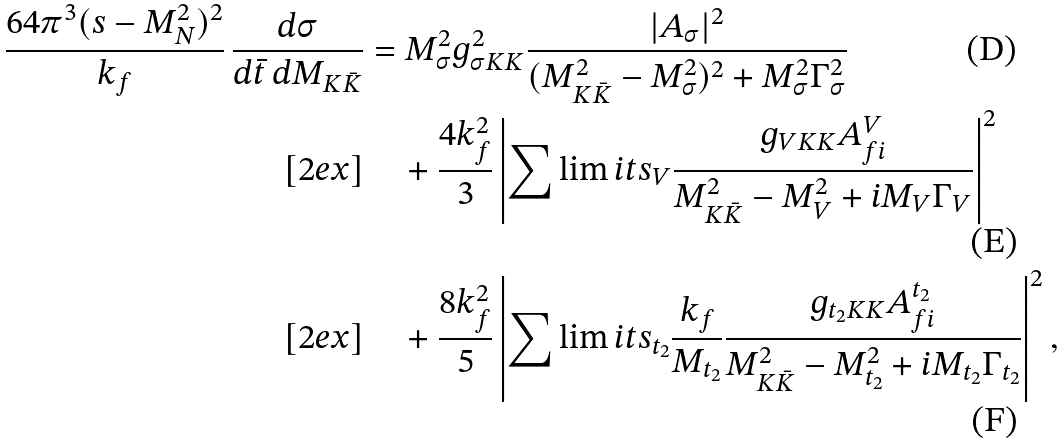Convert formula to latex. <formula><loc_0><loc_0><loc_500><loc_500>\frac { 6 4 \pi ^ { 3 } ( s - M _ { N } ^ { 2 } ) ^ { 2 } } { k _ { f } } \, \frac { d \sigma } { d \bar { t } \, d M _ { K \bar { K } } } & = M _ { \sigma } ^ { 2 } g ^ { 2 } _ { \sigma K K } \frac { | A _ { \sigma } | ^ { 2 } } { ( M _ { K \bar { K } } ^ { 2 } - M _ { \sigma } ^ { 2 } ) ^ { 2 } + M _ { \sigma } ^ { 2 } \Gamma _ { \sigma } ^ { 2 } } \\ [ 2 e x ] & \quad + \frac { 4 k _ { f } ^ { 2 } } { 3 } \left | \sum \lim i t s _ { V } \frac { g _ { V K K } A ^ { V } _ { f i } } { M _ { K \bar { K } } ^ { 2 } - M _ { V } ^ { 2 } + i M _ { V } \Gamma _ { V } } \right | ^ { 2 } \\ [ 2 e x ] & \quad + \frac { 8 k _ { f } ^ { 2 } } { 5 } \left | \sum \lim i t s _ { t _ { 2 } } \frac { k _ { f } } { M _ { t _ { 2 } } } \frac { g _ { t _ { 2 } K K } A ^ { t _ { 2 } } _ { f i } } { M _ { K \bar { K } } ^ { 2 } - M _ { t _ { 2 } } ^ { 2 } + i M _ { t _ { 2 } } \Gamma _ { t _ { 2 } } } \right | ^ { 2 } ,</formula> 